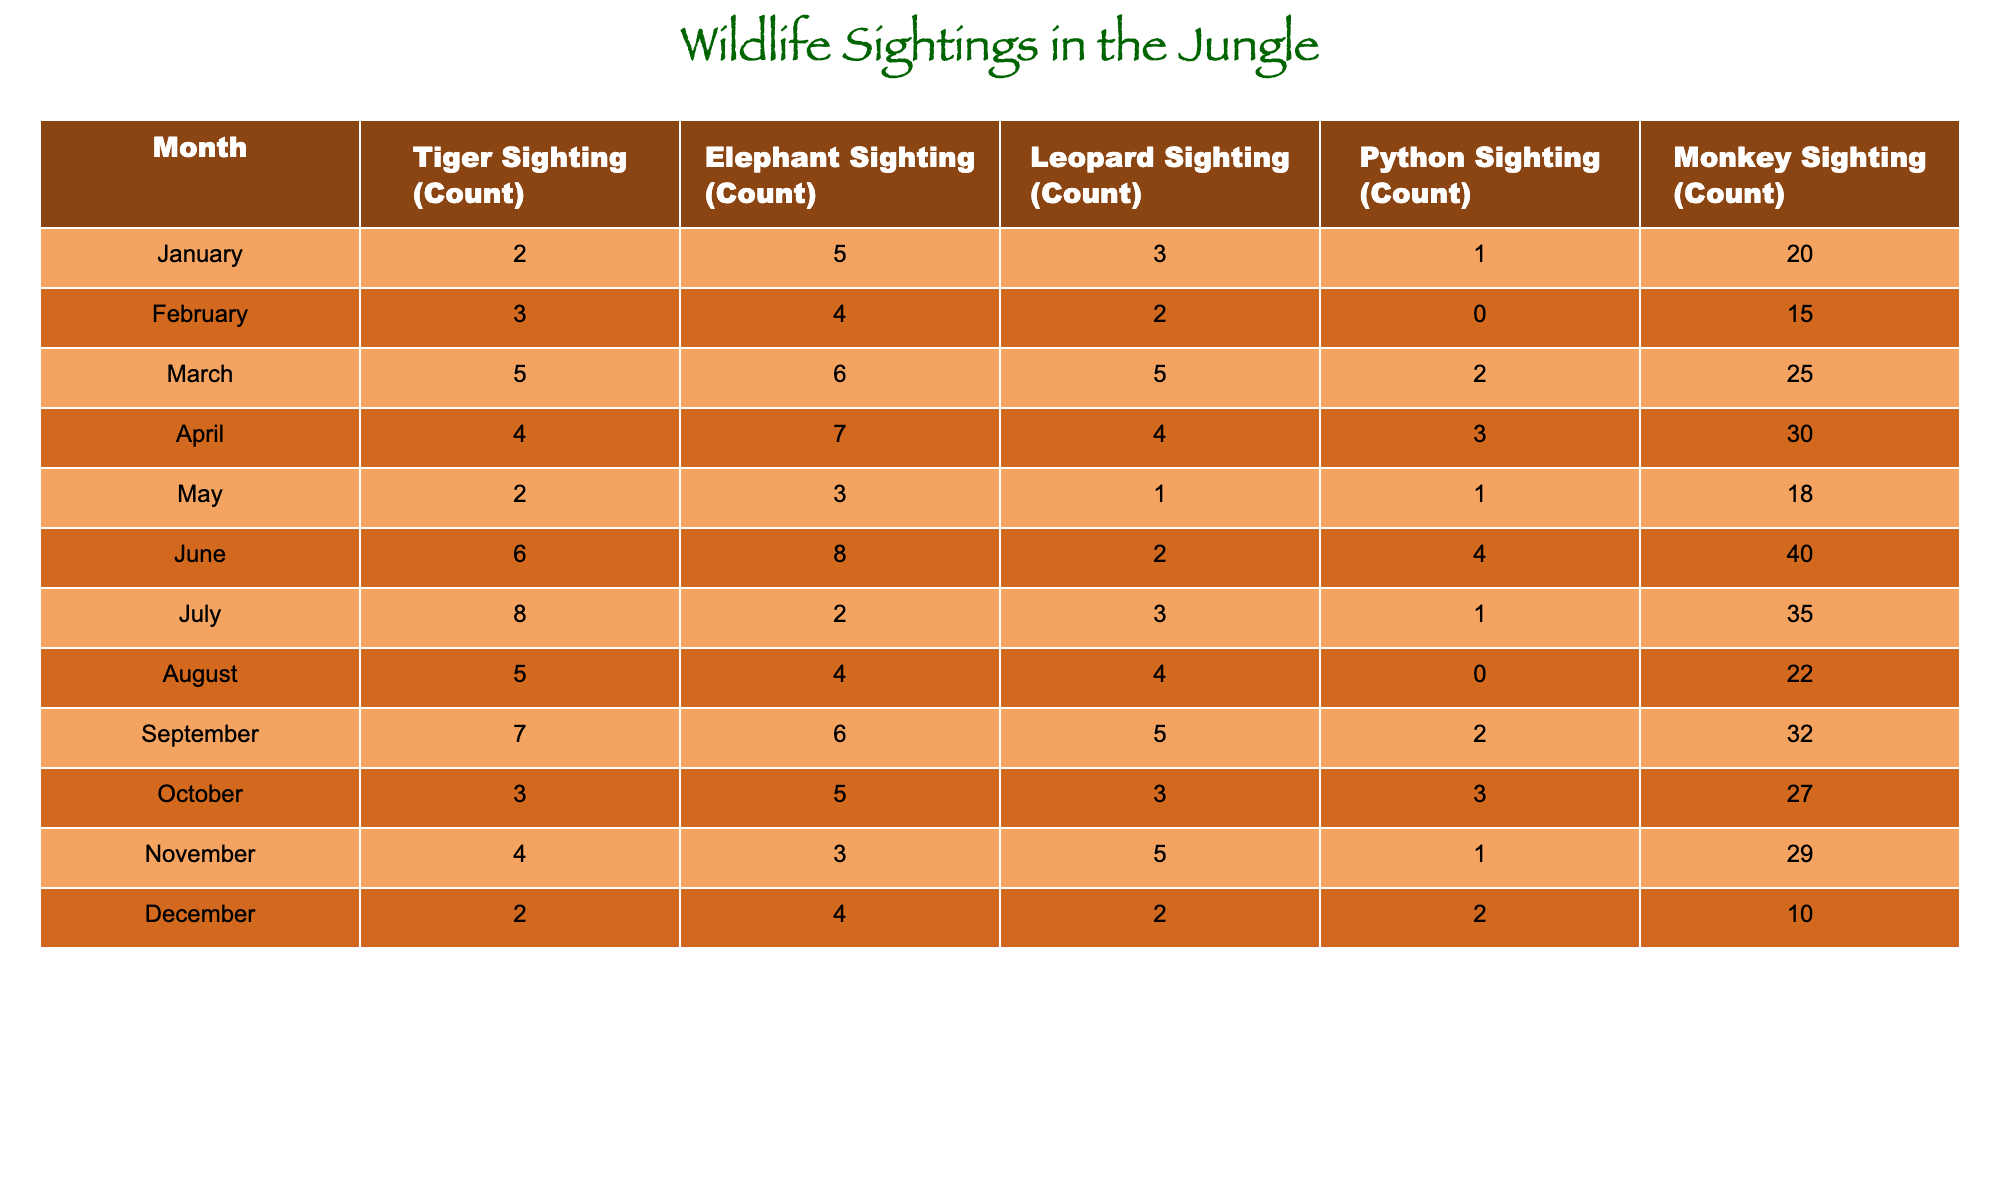What month had the highest tiger sightings? By examining the 'Tiger Sighting (Count)' column, we see the values: 2, 3, 5, 4, 2, 6, 8, 5, 7, 3, 4, 2. The maximum value is 8, which occurs in July.
Answer: July How many total elephant sightings were recorded from January to December? To find the total, we add the values in the 'Elephant Sighting (Count)' column: 5 + 4 + 6 + 7 + 3 + 8 + 2 + 4 + 6 + 5 + 3 + 4 = 57.
Answer: 57 Which month had the least monkey sightings? Looking at the 'Monkey Sighting (Count)' column, the values are: 20, 15, 25, 30, 18, 40, 35, 22, 32, 27, 29, 10. The minimum value is 10, which is in December.
Answer: December What is the average number of leopard sightings throughout the year? The leopard sightings are: 3, 2, 5, 4, 1, 2, 3, 4, 5, 3, 5, 2. Summing these gives 3+2+5+4+1+2+3+4+5+3+5+2 = 3. So, the total is 37. There are 12 months, hence the average is 37/12 = 3.08.
Answer: 3.08 Was there ever a month where the python sightings were zero? In the 'Python Sighting (Count)' column, the values are: 1, 0, 2, 3, 1, 4, 1, 0, 2, 3, 1, 2. The value '0' appears in February and August, which confirms that there were months with no python sightings.
Answer: Yes Which sighting type had the highest total sightings across all months? We sum each type of sighting: Tigers = 2+3+5+4+2+6+8+5+7+3+4+2 = 57, Elephants = 57 (as calculated earlier), Leopards = 3+2+5+4+1+2+3+4+5+3+5+2 = 43, Pythons = 1+0+2+3+1+4+1+0+2+3+1+2 = 20, Monkeys = 20+15+25+30+18+40+35+22+32+27+29+10 =  33. Comparing totals: Elephants have the highest total.
Answer: Elephants What is the difference between the highest and lowest monkey sighting months? The highest number of monkey sightings is 40 in June, and the lowest is 10 in December. The difference is 40 - 10 = 30.
Answer: 30 In which month do all animal sightings remain below 5 in count? Checking each month's counts for all sightings: January (5, 3, 1), February (4, 2, 0), May (3, 1, 1), and July (2, 3, 1). None stays below 5 for all, hence, no month satisfies this condition.
Answer: None 